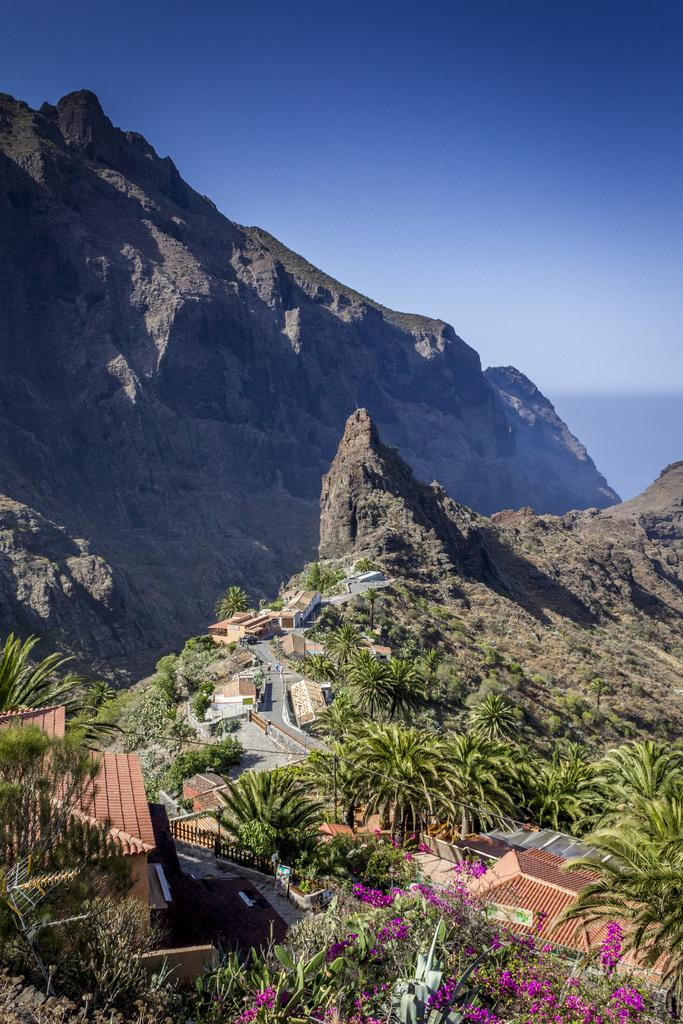Where was the picture taken? The picture was clicked outside the city. What can be seen in the center of the image? There are houses, trees, and rocks in the center of the image. What is visible in the background of the image? There is a hill and the sky visible in the background of the image. What type of acoustics can be heard in the image? There is no sound or acoustics present in the image, as it is a still photograph. Can you see a partner in the image? There is no person or partner visible in the image; it features houses, trees, rocks, a hill, and the sky. 